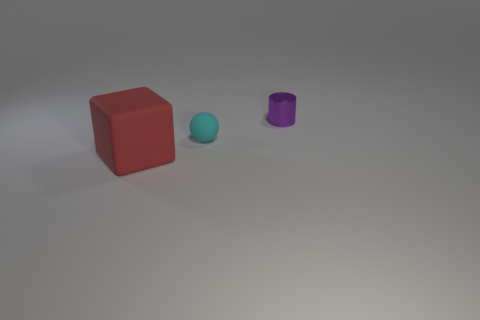Is the color of the tiny object on the left side of the purple shiny cylinder the same as the metallic cylinder?
Make the answer very short. No. There is a rubber thing behind the large matte object; is it the same size as the thing behind the matte ball?
Offer a very short reply. Yes. What is the size of the cyan ball that is the same material as the red block?
Your response must be concise. Small. How many small objects are both behind the ball and in front of the small purple cylinder?
Your answer should be compact. 0. What number of things are either matte balls or objects that are left of the small matte thing?
Offer a terse response. 2. There is a matte object behind the red rubber cube; what color is it?
Ensure brevity in your answer.  Cyan. How many objects are small things that are in front of the shiny cylinder or tiny yellow metallic cylinders?
Make the answer very short. 1. What is the color of the object that is the same size as the metallic cylinder?
Offer a very short reply. Cyan. Is the number of large things behind the rubber sphere greater than the number of purple shiny cylinders?
Give a very brief answer. No. What material is the thing that is both behind the large red block and left of the purple cylinder?
Give a very brief answer. Rubber. 